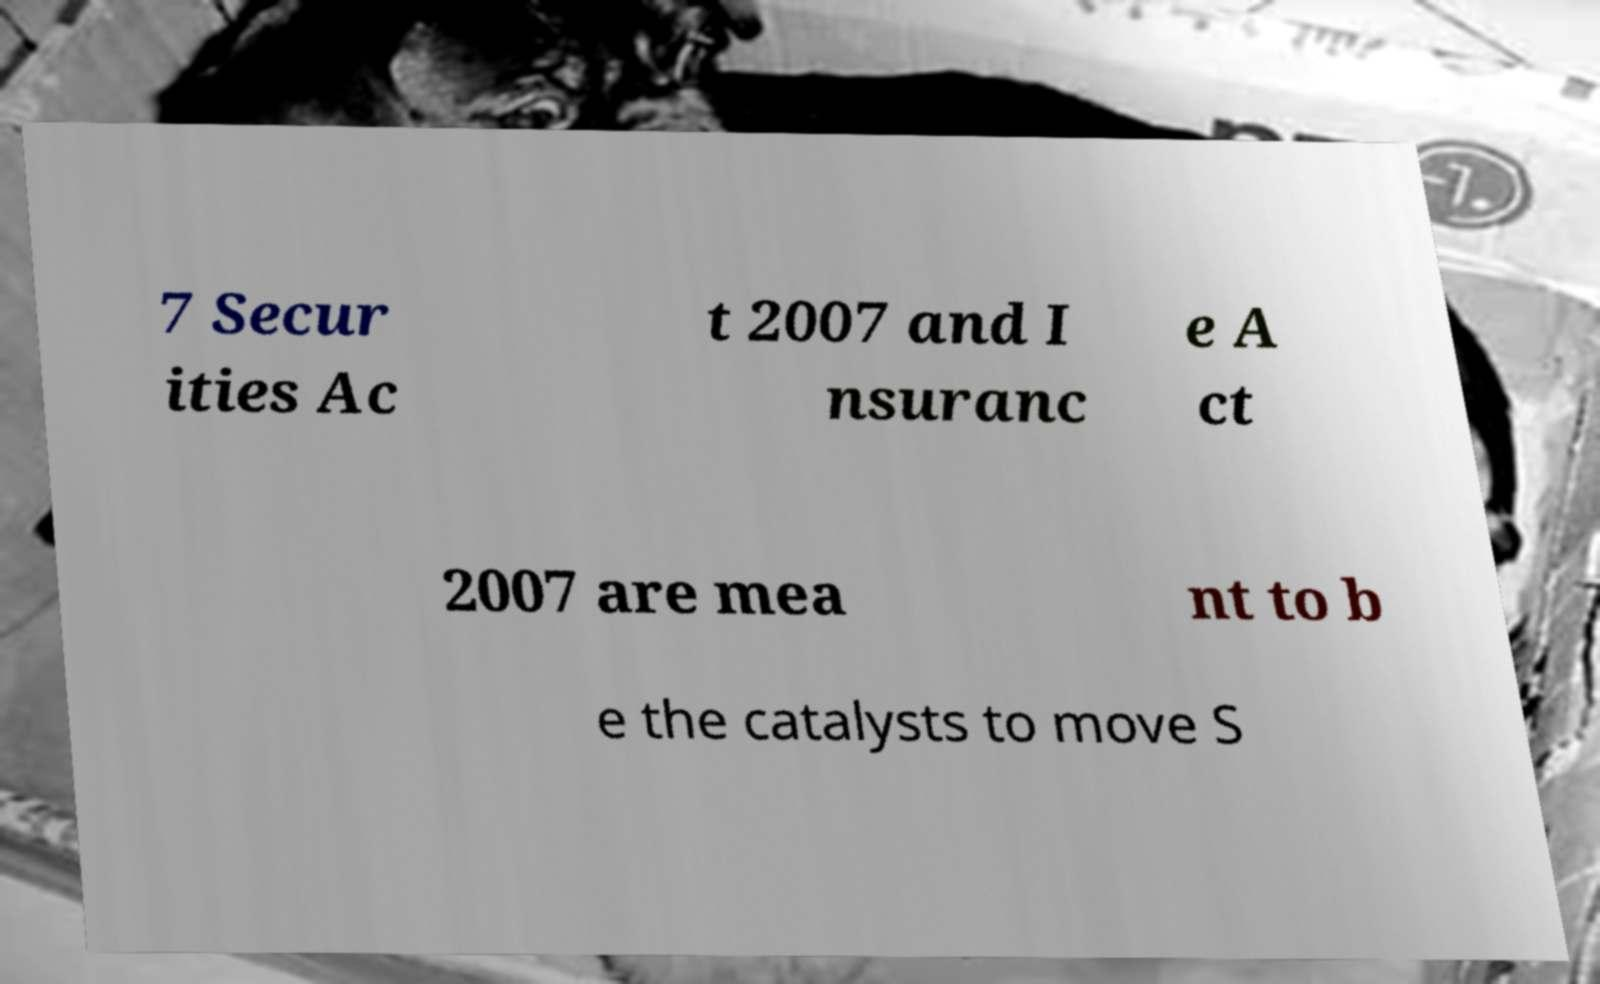Can you accurately transcribe the text from the provided image for me? 7 Secur ities Ac t 2007 and I nsuranc e A ct 2007 are mea nt to b e the catalysts to move S 